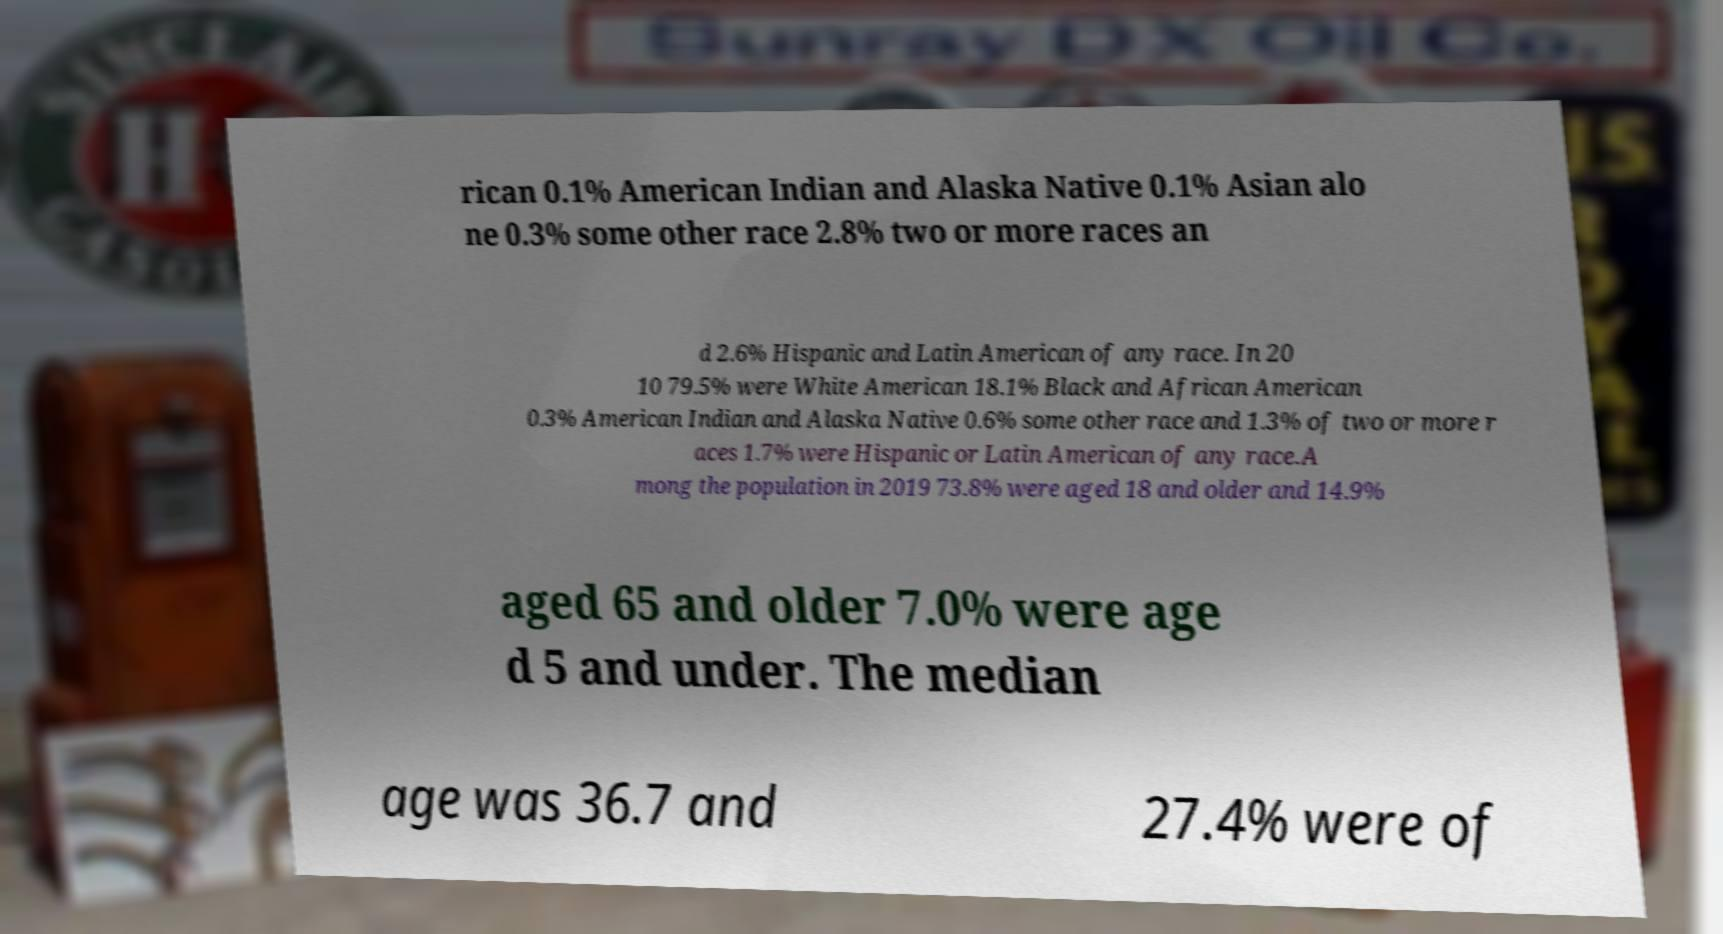For documentation purposes, I need the text within this image transcribed. Could you provide that? rican 0.1% American Indian and Alaska Native 0.1% Asian alo ne 0.3% some other race 2.8% two or more races an d 2.6% Hispanic and Latin American of any race. In 20 10 79.5% were White American 18.1% Black and African American 0.3% American Indian and Alaska Native 0.6% some other race and 1.3% of two or more r aces 1.7% were Hispanic or Latin American of any race.A mong the population in 2019 73.8% were aged 18 and older and 14.9% aged 65 and older 7.0% were age d 5 and under. The median age was 36.7 and 27.4% were of 